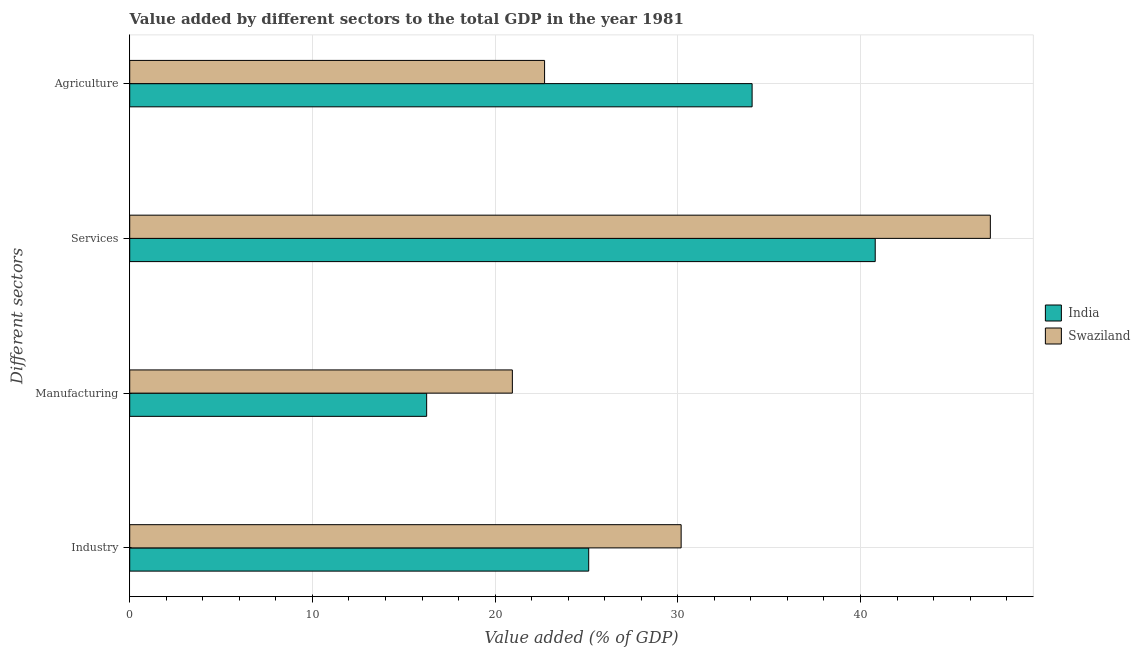How many different coloured bars are there?
Give a very brief answer. 2. Are the number of bars per tick equal to the number of legend labels?
Provide a short and direct response. Yes. Are the number of bars on each tick of the Y-axis equal?
Your response must be concise. Yes. What is the label of the 3rd group of bars from the top?
Your answer should be compact. Manufacturing. What is the value added by agricultural sector in Swaziland?
Offer a terse response. 22.71. Across all countries, what is the maximum value added by services sector?
Make the answer very short. 47.11. Across all countries, what is the minimum value added by services sector?
Offer a terse response. 40.81. In which country was the value added by industrial sector maximum?
Make the answer very short. Swaziland. What is the total value added by agricultural sector in the graph?
Give a very brief answer. 56.78. What is the difference between the value added by services sector in Swaziland and that in India?
Provide a succinct answer. 6.3. What is the difference between the value added by agricultural sector in India and the value added by manufacturing sector in Swaziland?
Provide a succinct answer. 13.12. What is the average value added by agricultural sector per country?
Make the answer very short. 28.39. What is the difference between the value added by manufacturing sector and value added by industrial sector in India?
Your answer should be very brief. -8.87. What is the ratio of the value added by services sector in India to that in Swaziland?
Provide a short and direct response. 0.87. What is the difference between the highest and the second highest value added by services sector?
Make the answer very short. 6.3. What is the difference between the highest and the lowest value added by manufacturing sector?
Keep it short and to the point. 4.69. In how many countries, is the value added by agricultural sector greater than the average value added by agricultural sector taken over all countries?
Provide a short and direct response. 1. Is the sum of the value added by industrial sector in India and Swaziland greater than the maximum value added by services sector across all countries?
Make the answer very short. Yes. Is it the case that in every country, the sum of the value added by industrial sector and value added by agricultural sector is greater than the sum of value added by services sector and value added by manufacturing sector?
Give a very brief answer. No. What does the 1st bar from the top in Services represents?
Keep it short and to the point. Swaziland. Is it the case that in every country, the sum of the value added by industrial sector and value added by manufacturing sector is greater than the value added by services sector?
Offer a terse response. Yes. How many bars are there?
Give a very brief answer. 8. How many countries are there in the graph?
Offer a very short reply. 2. What is the difference between two consecutive major ticks on the X-axis?
Provide a succinct answer. 10. Does the graph contain any zero values?
Provide a short and direct response. No. Does the graph contain grids?
Make the answer very short. Yes. Where does the legend appear in the graph?
Your answer should be compact. Center right. How many legend labels are there?
Ensure brevity in your answer.  2. What is the title of the graph?
Keep it short and to the point. Value added by different sectors to the total GDP in the year 1981. Does "Kiribati" appear as one of the legend labels in the graph?
Your answer should be very brief. No. What is the label or title of the X-axis?
Your answer should be very brief. Value added (% of GDP). What is the label or title of the Y-axis?
Provide a short and direct response. Different sectors. What is the Value added (% of GDP) in India in Industry?
Keep it short and to the point. 25.12. What is the Value added (% of GDP) of Swaziland in Industry?
Offer a terse response. 30.18. What is the Value added (% of GDP) in India in Manufacturing?
Provide a succinct answer. 16.25. What is the Value added (% of GDP) in Swaziland in Manufacturing?
Provide a succinct answer. 20.94. What is the Value added (% of GDP) in India in Services?
Your answer should be compact. 40.81. What is the Value added (% of GDP) in Swaziland in Services?
Your answer should be compact. 47.11. What is the Value added (% of GDP) in India in Agriculture?
Your response must be concise. 34.07. What is the Value added (% of GDP) in Swaziland in Agriculture?
Your answer should be compact. 22.71. Across all Different sectors, what is the maximum Value added (% of GDP) of India?
Offer a terse response. 40.81. Across all Different sectors, what is the maximum Value added (% of GDP) in Swaziland?
Make the answer very short. 47.11. Across all Different sectors, what is the minimum Value added (% of GDP) of India?
Your answer should be compact. 16.25. Across all Different sectors, what is the minimum Value added (% of GDP) of Swaziland?
Make the answer very short. 20.94. What is the total Value added (% of GDP) in India in the graph?
Offer a very short reply. 116.25. What is the total Value added (% of GDP) in Swaziland in the graph?
Keep it short and to the point. 120.94. What is the difference between the Value added (% of GDP) in India in Industry and that in Manufacturing?
Ensure brevity in your answer.  8.87. What is the difference between the Value added (% of GDP) of Swaziland in Industry and that in Manufacturing?
Your answer should be compact. 9.24. What is the difference between the Value added (% of GDP) of India in Industry and that in Services?
Give a very brief answer. -15.68. What is the difference between the Value added (% of GDP) in Swaziland in Industry and that in Services?
Give a very brief answer. -16.93. What is the difference between the Value added (% of GDP) of India in Industry and that in Agriculture?
Ensure brevity in your answer.  -8.95. What is the difference between the Value added (% of GDP) in Swaziland in Industry and that in Agriculture?
Ensure brevity in your answer.  7.48. What is the difference between the Value added (% of GDP) in India in Manufacturing and that in Services?
Provide a short and direct response. -24.55. What is the difference between the Value added (% of GDP) in Swaziland in Manufacturing and that in Services?
Offer a terse response. -26.16. What is the difference between the Value added (% of GDP) of India in Manufacturing and that in Agriculture?
Make the answer very short. -17.82. What is the difference between the Value added (% of GDP) in Swaziland in Manufacturing and that in Agriculture?
Offer a very short reply. -1.76. What is the difference between the Value added (% of GDP) of India in Services and that in Agriculture?
Give a very brief answer. 6.74. What is the difference between the Value added (% of GDP) of Swaziland in Services and that in Agriculture?
Provide a succinct answer. 24.4. What is the difference between the Value added (% of GDP) in India in Industry and the Value added (% of GDP) in Swaziland in Manufacturing?
Your answer should be very brief. 4.18. What is the difference between the Value added (% of GDP) of India in Industry and the Value added (% of GDP) of Swaziland in Services?
Offer a terse response. -21.98. What is the difference between the Value added (% of GDP) of India in Industry and the Value added (% of GDP) of Swaziland in Agriculture?
Keep it short and to the point. 2.42. What is the difference between the Value added (% of GDP) of India in Manufacturing and the Value added (% of GDP) of Swaziland in Services?
Provide a short and direct response. -30.86. What is the difference between the Value added (% of GDP) in India in Manufacturing and the Value added (% of GDP) in Swaziland in Agriculture?
Make the answer very short. -6.45. What is the difference between the Value added (% of GDP) of India in Services and the Value added (% of GDP) of Swaziland in Agriculture?
Offer a very short reply. 18.1. What is the average Value added (% of GDP) of India per Different sectors?
Provide a succinct answer. 29.06. What is the average Value added (% of GDP) in Swaziland per Different sectors?
Your response must be concise. 30.24. What is the difference between the Value added (% of GDP) of India and Value added (% of GDP) of Swaziland in Industry?
Offer a very short reply. -5.06. What is the difference between the Value added (% of GDP) of India and Value added (% of GDP) of Swaziland in Manufacturing?
Make the answer very short. -4.69. What is the difference between the Value added (% of GDP) in India and Value added (% of GDP) in Swaziland in Services?
Your response must be concise. -6.3. What is the difference between the Value added (% of GDP) of India and Value added (% of GDP) of Swaziland in Agriculture?
Offer a terse response. 11.36. What is the ratio of the Value added (% of GDP) of India in Industry to that in Manufacturing?
Ensure brevity in your answer.  1.55. What is the ratio of the Value added (% of GDP) in Swaziland in Industry to that in Manufacturing?
Make the answer very short. 1.44. What is the ratio of the Value added (% of GDP) in India in Industry to that in Services?
Your answer should be very brief. 0.62. What is the ratio of the Value added (% of GDP) in Swaziland in Industry to that in Services?
Your answer should be compact. 0.64. What is the ratio of the Value added (% of GDP) in India in Industry to that in Agriculture?
Make the answer very short. 0.74. What is the ratio of the Value added (% of GDP) in Swaziland in Industry to that in Agriculture?
Your answer should be very brief. 1.33. What is the ratio of the Value added (% of GDP) of India in Manufacturing to that in Services?
Keep it short and to the point. 0.4. What is the ratio of the Value added (% of GDP) in Swaziland in Manufacturing to that in Services?
Ensure brevity in your answer.  0.44. What is the ratio of the Value added (% of GDP) in India in Manufacturing to that in Agriculture?
Your response must be concise. 0.48. What is the ratio of the Value added (% of GDP) in Swaziland in Manufacturing to that in Agriculture?
Your answer should be compact. 0.92. What is the ratio of the Value added (% of GDP) of India in Services to that in Agriculture?
Your answer should be very brief. 1.2. What is the ratio of the Value added (% of GDP) in Swaziland in Services to that in Agriculture?
Your answer should be very brief. 2.07. What is the difference between the highest and the second highest Value added (% of GDP) of India?
Offer a very short reply. 6.74. What is the difference between the highest and the second highest Value added (% of GDP) in Swaziland?
Make the answer very short. 16.93. What is the difference between the highest and the lowest Value added (% of GDP) in India?
Make the answer very short. 24.55. What is the difference between the highest and the lowest Value added (% of GDP) in Swaziland?
Offer a terse response. 26.16. 